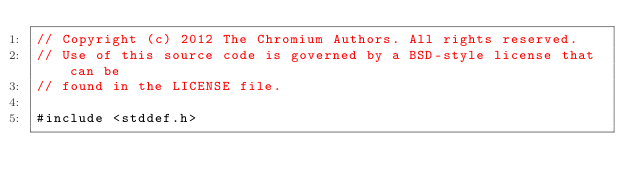Convert code to text. <code><loc_0><loc_0><loc_500><loc_500><_ObjectiveC_>// Copyright (c) 2012 The Chromium Authors. All rights reserved.
// Use of this source code is governed by a BSD-style license that can be
// found in the LICENSE file.

#include <stddef.h>
</code> 